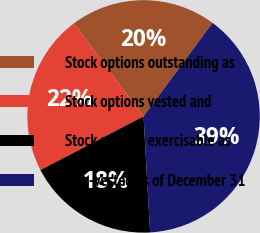Convert chart to OTSL. <chart><loc_0><loc_0><loc_500><loc_500><pie_chart><fcel>Stock options outstanding as<fcel>Stock options vested and<fcel>Stock options exercisable as<fcel>Non-vested as of December 31<nl><fcel>20.34%<fcel>22.41%<fcel>18.26%<fcel>38.99%<nl></chart> 